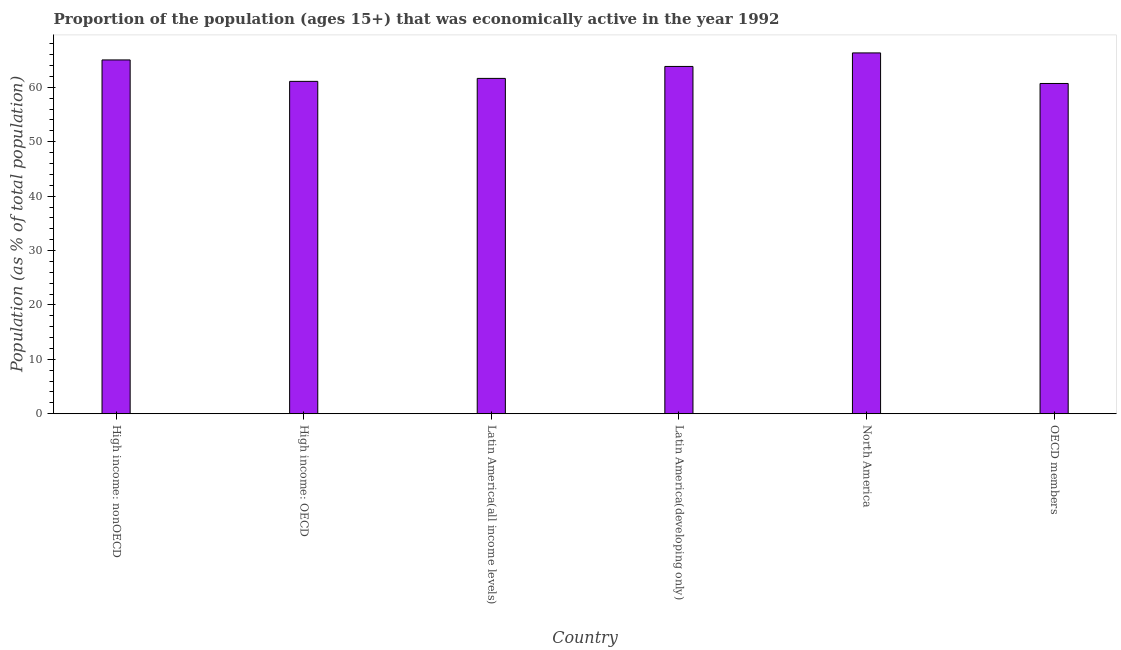Does the graph contain any zero values?
Your response must be concise. No. What is the title of the graph?
Your answer should be very brief. Proportion of the population (ages 15+) that was economically active in the year 1992. What is the label or title of the X-axis?
Ensure brevity in your answer.  Country. What is the label or title of the Y-axis?
Provide a succinct answer. Population (as % of total population). What is the percentage of economically active population in Latin America(developing only)?
Your answer should be compact. 63.84. Across all countries, what is the maximum percentage of economically active population?
Your response must be concise. 66.33. Across all countries, what is the minimum percentage of economically active population?
Give a very brief answer. 60.71. What is the sum of the percentage of economically active population?
Offer a terse response. 378.67. What is the difference between the percentage of economically active population in Latin America(all income levels) and Latin America(developing only)?
Ensure brevity in your answer.  -2.2. What is the average percentage of economically active population per country?
Give a very brief answer. 63.11. What is the median percentage of economically active population?
Keep it short and to the point. 62.74. Is the percentage of economically active population in High income: OECD less than that in OECD members?
Your answer should be very brief. No. Is the difference between the percentage of economically active population in Latin America(all income levels) and OECD members greater than the difference between any two countries?
Give a very brief answer. No. What is the difference between the highest and the second highest percentage of economically active population?
Your answer should be very brief. 1.29. Is the sum of the percentage of economically active population in High income: nonOECD and OECD members greater than the maximum percentage of economically active population across all countries?
Offer a very short reply. Yes. What is the difference between the highest and the lowest percentage of economically active population?
Provide a short and direct response. 5.62. In how many countries, is the percentage of economically active population greater than the average percentage of economically active population taken over all countries?
Your answer should be compact. 3. How many countries are there in the graph?
Your answer should be compact. 6. What is the difference between two consecutive major ticks on the Y-axis?
Provide a succinct answer. 10. What is the Population (as % of total population) of High income: nonOECD?
Offer a very short reply. 65.04. What is the Population (as % of total population) in High income: OECD?
Keep it short and to the point. 61.1. What is the Population (as % of total population) of Latin America(all income levels)?
Ensure brevity in your answer.  61.65. What is the Population (as % of total population) in Latin America(developing only)?
Provide a succinct answer. 63.84. What is the Population (as % of total population) of North America?
Make the answer very short. 66.33. What is the Population (as % of total population) in OECD members?
Offer a terse response. 60.71. What is the difference between the Population (as % of total population) in High income: nonOECD and High income: OECD?
Give a very brief answer. 3.94. What is the difference between the Population (as % of total population) in High income: nonOECD and Latin America(all income levels)?
Your answer should be compact. 3.39. What is the difference between the Population (as % of total population) in High income: nonOECD and Latin America(developing only)?
Your answer should be compact. 1.2. What is the difference between the Population (as % of total population) in High income: nonOECD and North America?
Offer a terse response. -1.29. What is the difference between the Population (as % of total population) in High income: nonOECD and OECD members?
Keep it short and to the point. 4.33. What is the difference between the Population (as % of total population) in High income: OECD and Latin America(all income levels)?
Your response must be concise. -0.55. What is the difference between the Population (as % of total population) in High income: OECD and Latin America(developing only)?
Provide a short and direct response. -2.74. What is the difference between the Population (as % of total population) in High income: OECD and North America?
Offer a very short reply. -5.23. What is the difference between the Population (as % of total population) in High income: OECD and OECD members?
Your answer should be very brief. 0.39. What is the difference between the Population (as % of total population) in Latin America(all income levels) and Latin America(developing only)?
Ensure brevity in your answer.  -2.2. What is the difference between the Population (as % of total population) in Latin America(all income levels) and North America?
Provide a succinct answer. -4.68. What is the difference between the Population (as % of total population) in Latin America(all income levels) and OECD members?
Provide a short and direct response. 0.93. What is the difference between the Population (as % of total population) in Latin America(developing only) and North America?
Keep it short and to the point. -2.49. What is the difference between the Population (as % of total population) in Latin America(developing only) and OECD members?
Keep it short and to the point. 3.13. What is the difference between the Population (as % of total population) in North America and OECD members?
Your response must be concise. 5.62. What is the ratio of the Population (as % of total population) in High income: nonOECD to that in High income: OECD?
Keep it short and to the point. 1.06. What is the ratio of the Population (as % of total population) in High income: nonOECD to that in Latin America(all income levels)?
Your answer should be very brief. 1.05. What is the ratio of the Population (as % of total population) in High income: nonOECD to that in OECD members?
Provide a short and direct response. 1.07. What is the ratio of the Population (as % of total population) in High income: OECD to that in North America?
Your answer should be compact. 0.92. What is the ratio of the Population (as % of total population) in High income: OECD to that in OECD members?
Provide a succinct answer. 1.01. What is the ratio of the Population (as % of total population) in Latin America(all income levels) to that in Latin America(developing only)?
Your response must be concise. 0.97. What is the ratio of the Population (as % of total population) in Latin America(all income levels) to that in North America?
Offer a very short reply. 0.93. What is the ratio of the Population (as % of total population) in Latin America(developing only) to that in North America?
Ensure brevity in your answer.  0.96. What is the ratio of the Population (as % of total population) in Latin America(developing only) to that in OECD members?
Your answer should be compact. 1.05. What is the ratio of the Population (as % of total population) in North America to that in OECD members?
Your response must be concise. 1.09. 